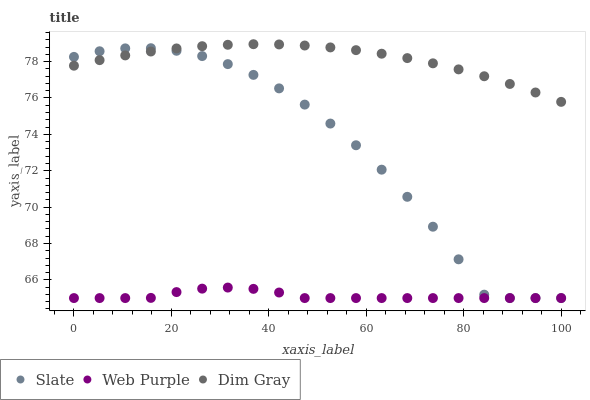Does Web Purple have the minimum area under the curve?
Answer yes or no. Yes. Does Dim Gray have the maximum area under the curve?
Answer yes or no. Yes. Does Dim Gray have the minimum area under the curve?
Answer yes or no. No. Does Web Purple have the maximum area under the curve?
Answer yes or no. No. Is Dim Gray the smoothest?
Answer yes or no. Yes. Is Slate the roughest?
Answer yes or no. Yes. Is Web Purple the smoothest?
Answer yes or no. No. Is Web Purple the roughest?
Answer yes or no. No. Does Slate have the lowest value?
Answer yes or no. Yes. Does Dim Gray have the lowest value?
Answer yes or no. No. Does Dim Gray have the highest value?
Answer yes or no. Yes. Does Web Purple have the highest value?
Answer yes or no. No. Is Web Purple less than Dim Gray?
Answer yes or no. Yes. Is Dim Gray greater than Web Purple?
Answer yes or no. Yes. Does Slate intersect Dim Gray?
Answer yes or no. Yes. Is Slate less than Dim Gray?
Answer yes or no. No. Is Slate greater than Dim Gray?
Answer yes or no. No. Does Web Purple intersect Dim Gray?
Answer yes or no. No. 